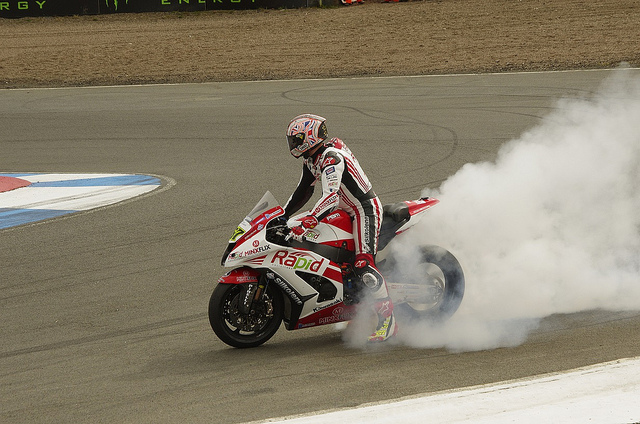Identify the text contained in this image. Rapid RGY 